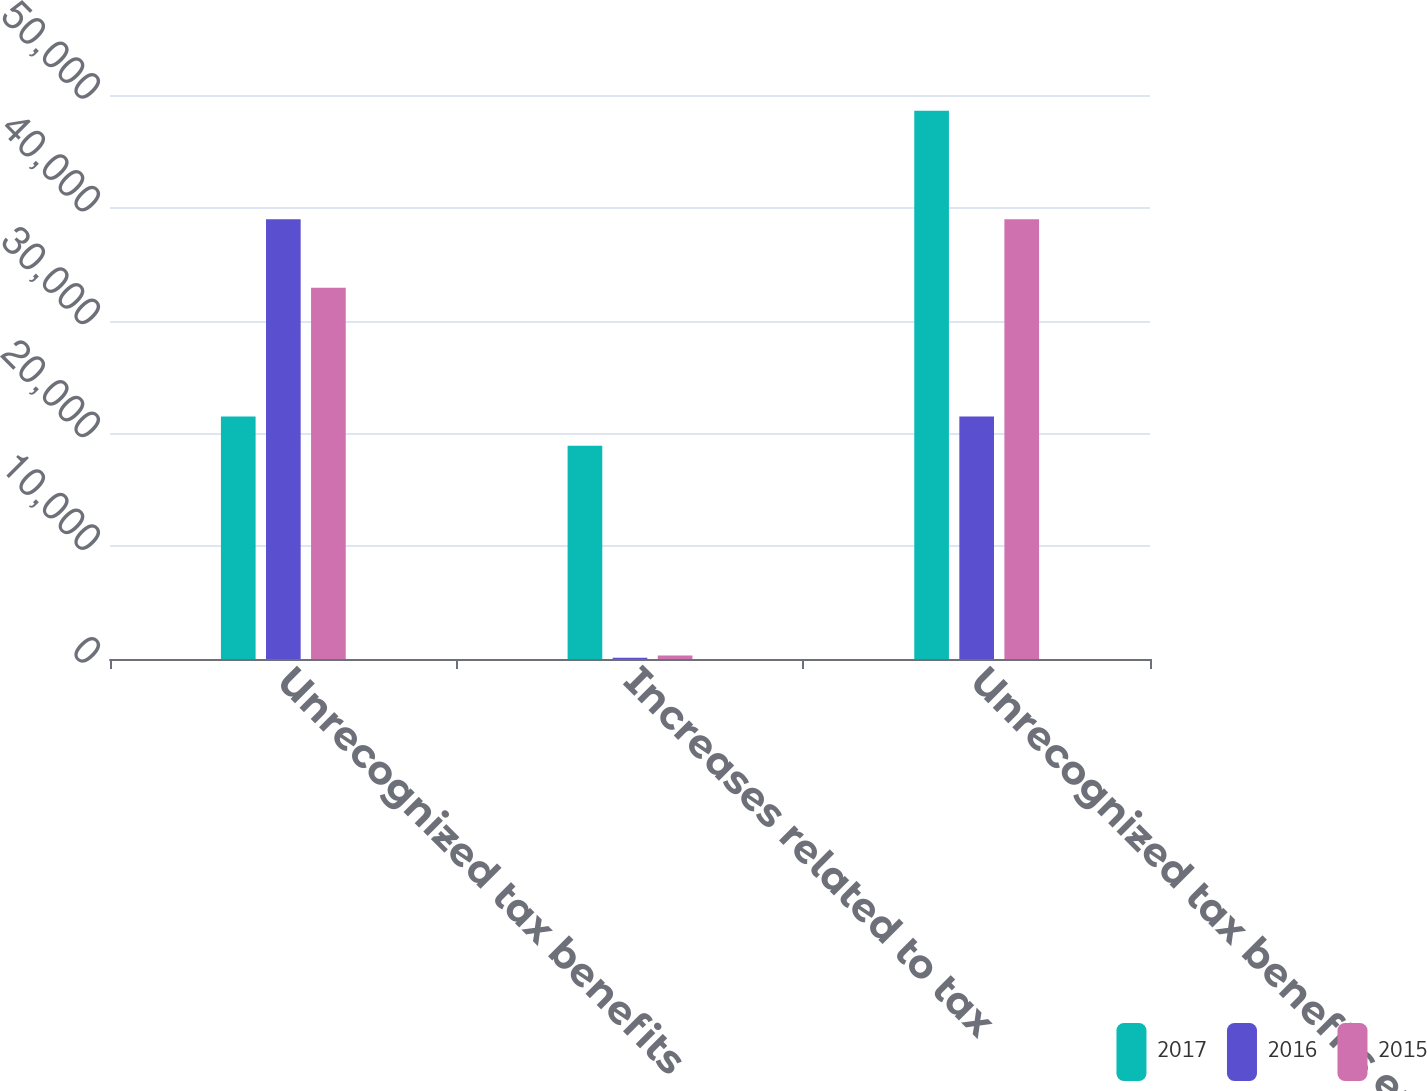Convert chart to OTSL. <chart><loc_0><loc_0><loc_500><loc_500><stacked_bar_chart><ecel><fcel>Unrecognized tax benefits<fcel>Increases related to tax<fcel>Unrecognized tax benefits end<nl><fcel>2017<fcel>21502<fcel>18895<fcel>48604<nl><fcel>2016<fcel>38992<fcel>114<fcel>21502<nl><fcel>2015<fcel>32911<fcel>318<fcel>38992<nl></chart> 